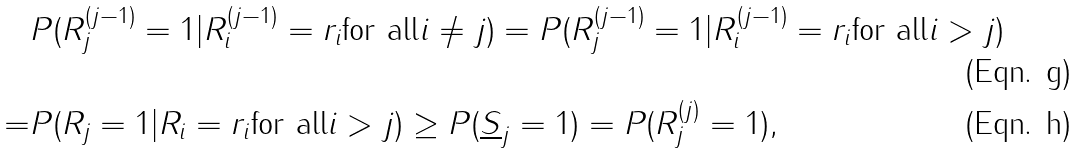<formula> <loc_0><loc_0><loc_500><loc_500>& P ( R _ { j } ^ { ( j - 1 ) } = 1 | R _ { i } ^ { ( j - 1 ) } = r _ { i } \text {for all} i \neq j ) = P ( R _ { j } ^ { ( j - 1 ) } = 1 | R _ { i } ^ { ( j - 1 ) } = r _ { i } \text {for all} i > j ) \\ = & P ( R _ { j } = 1 | R _ { i } = r _ { i } \text {for all} i > j ) \geq P ( \underline { S } _ { j } = 1 ) = P ( R _ { j } ^ { ( j ) } = 1 ) ,</formula> 